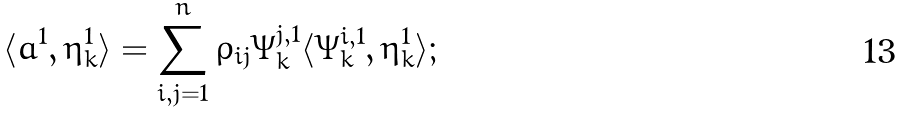<formula> <loc_0><loc_0><loc_500><loc_500>\langle a ^ { 1 } , \eta ^ { 1 } _ { k } \rangle = \sum _ { i , j = 1 } ^ { n } \rho _ { i j } \Psi ^ { j , 1 } _ { k } \langle \Psi ^ { i , 1 } _ { k } , \eta ^ { 1 } _ { k } \rangle ;</formula> 